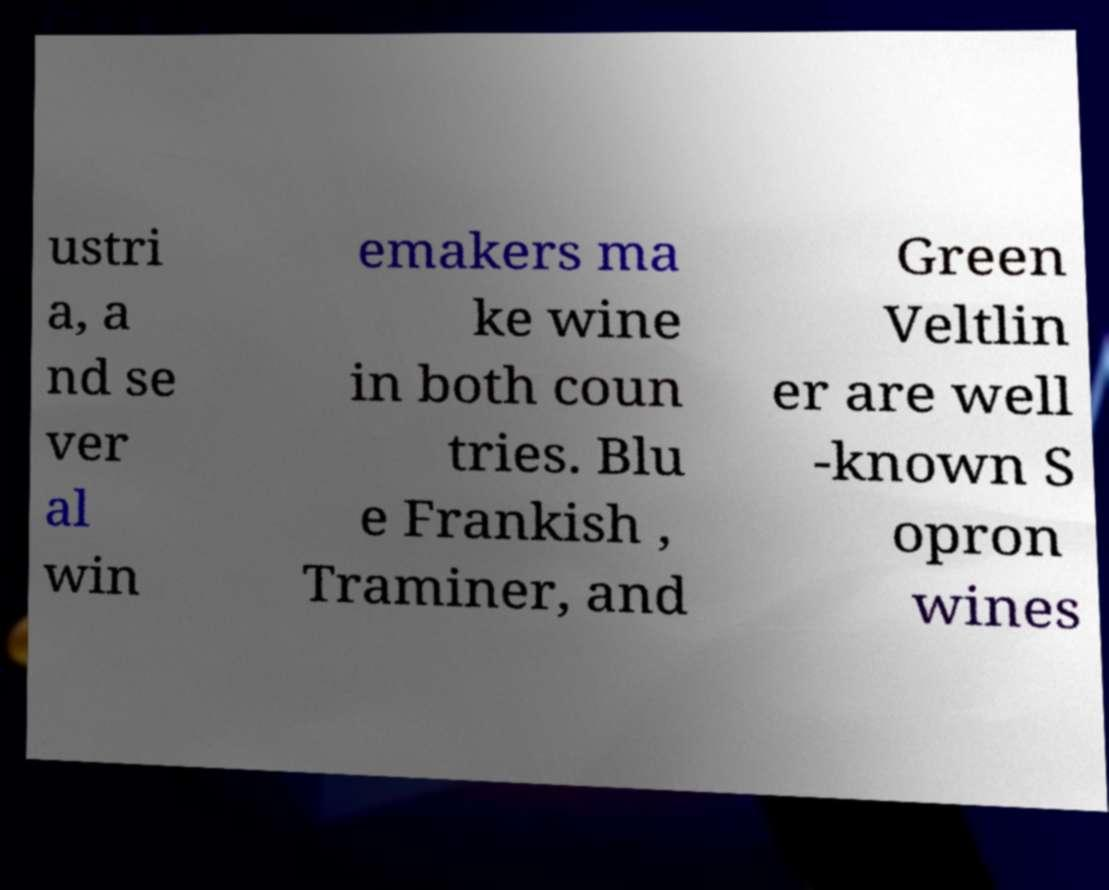I need the written content from this picture converted into text. Can you do that? ustri a, a nd se ver al win emakers ma ke wine in both coun tries. Blu e Frankish , Traminer, and Green Veltlin er are well -known S opron wines 